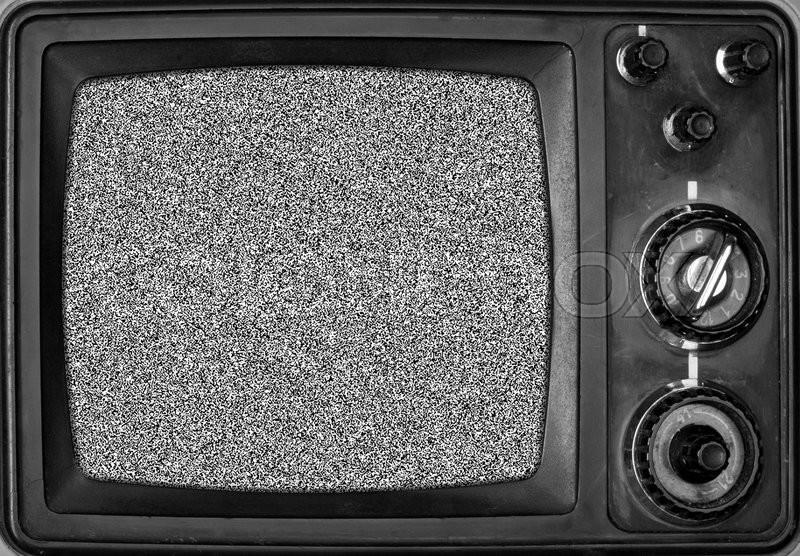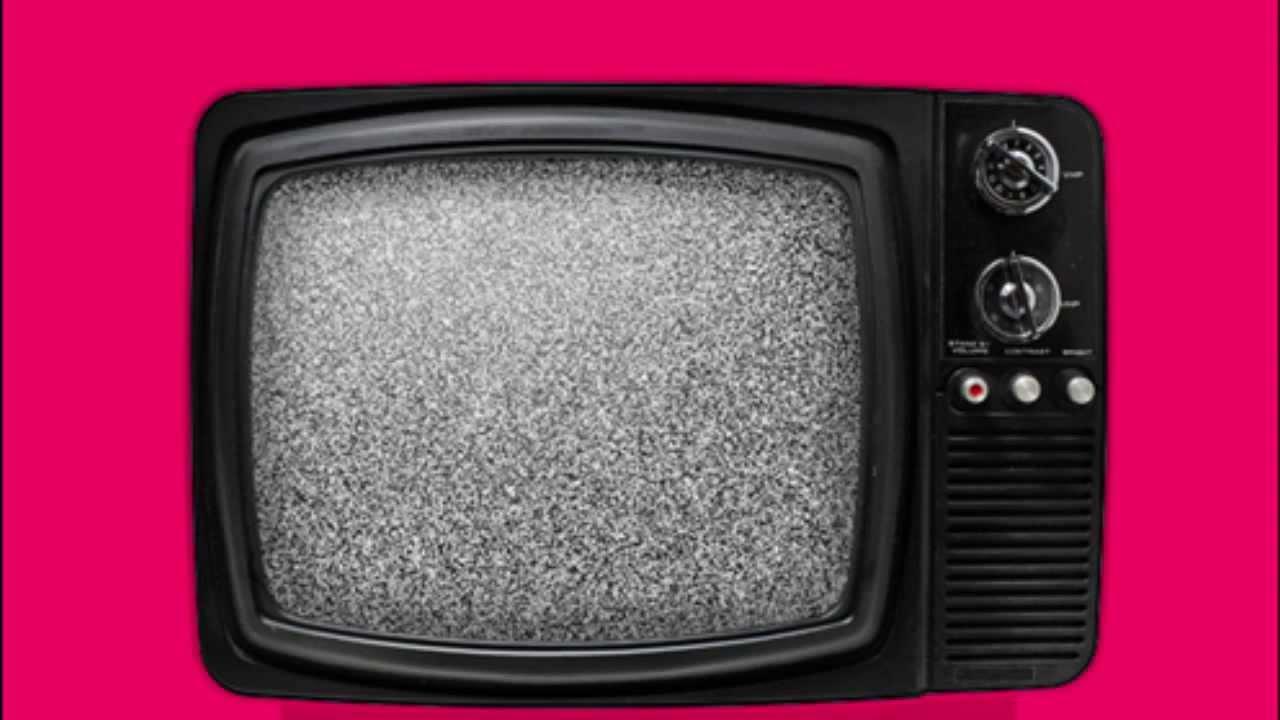The first image is the image on the left, the second image is the image on the right. For the images displayed, is the sentence "One of the television sets includes a color image." factually correct? Answer yes or no. No. The first image is the image on the left, the second image is the image on the right. Evaluate the accuracy of this statement regarding the images: "Each image shows one old-fashioned TV set with grainy static """"fuzz"""" on the screen, and the right image shows a TV set on a solid-colored background.". Is it true? Answer yes or no. Yes. 